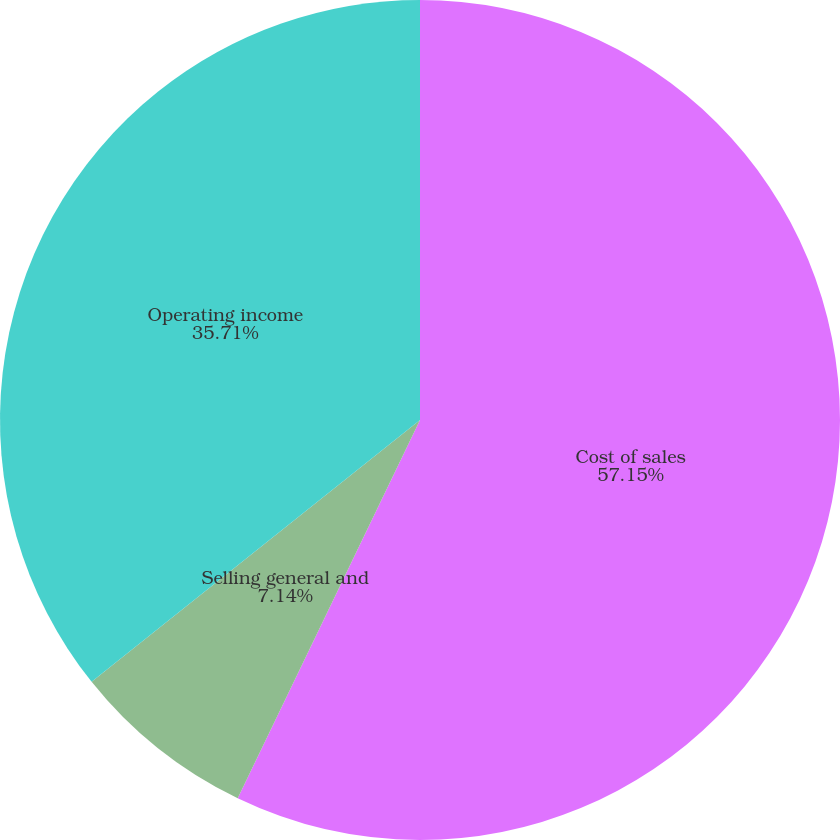Convert chart. <chart><loc_0><loc_0><loc_500><loc_500><pie_chart><fcel>Cost of sales<fcel>Selling general and<fcel>Operating income<nl><fcel>57.14%<fcel>7.14%<fcel>35.71%<nl></chart> 